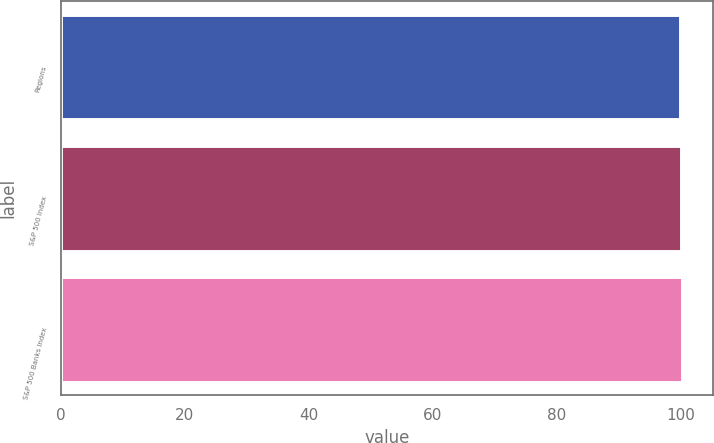Convert chart. <chart><loc_0><loc_0><loc_500><loc_500><bar_chart><fcel>Regions<fcel>S&P 500 Index<fcel>S&P 500 Banks Index<nl><fcel>100<fcel>100.1<fcel>100.2<nl></chart> 